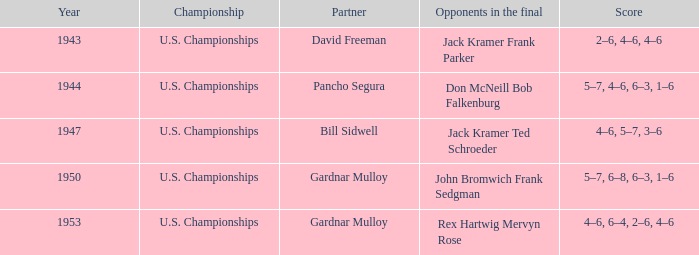Which Championship has a Score of 2–6, 4–6, 4–6? U.S. Championships. 